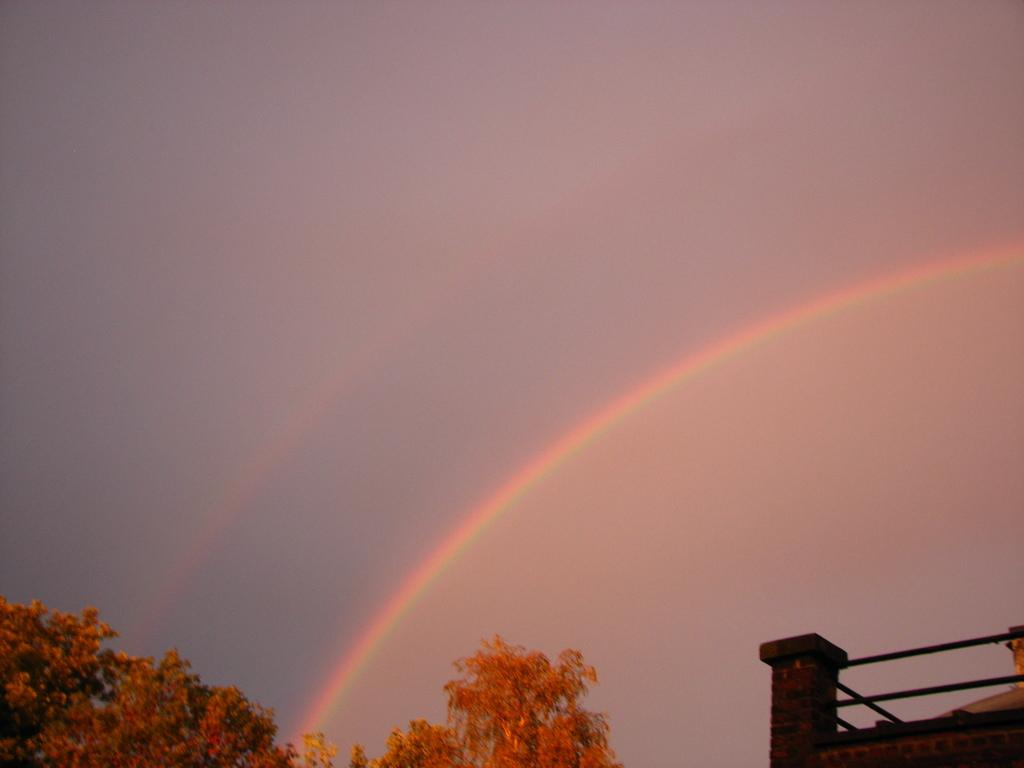What natural phenomenon can be seen in the sky in the image? There is a rainbow in the sky in the image. What type of vegetation is present in the image? There is a tree in the image. What type of man-made structure is visible in the image? There is a building in the image. What type of rock can be seen on the ground in the image? There is no rock visible on the ground in the image; it only features a rainbow, a tree, and a building. 